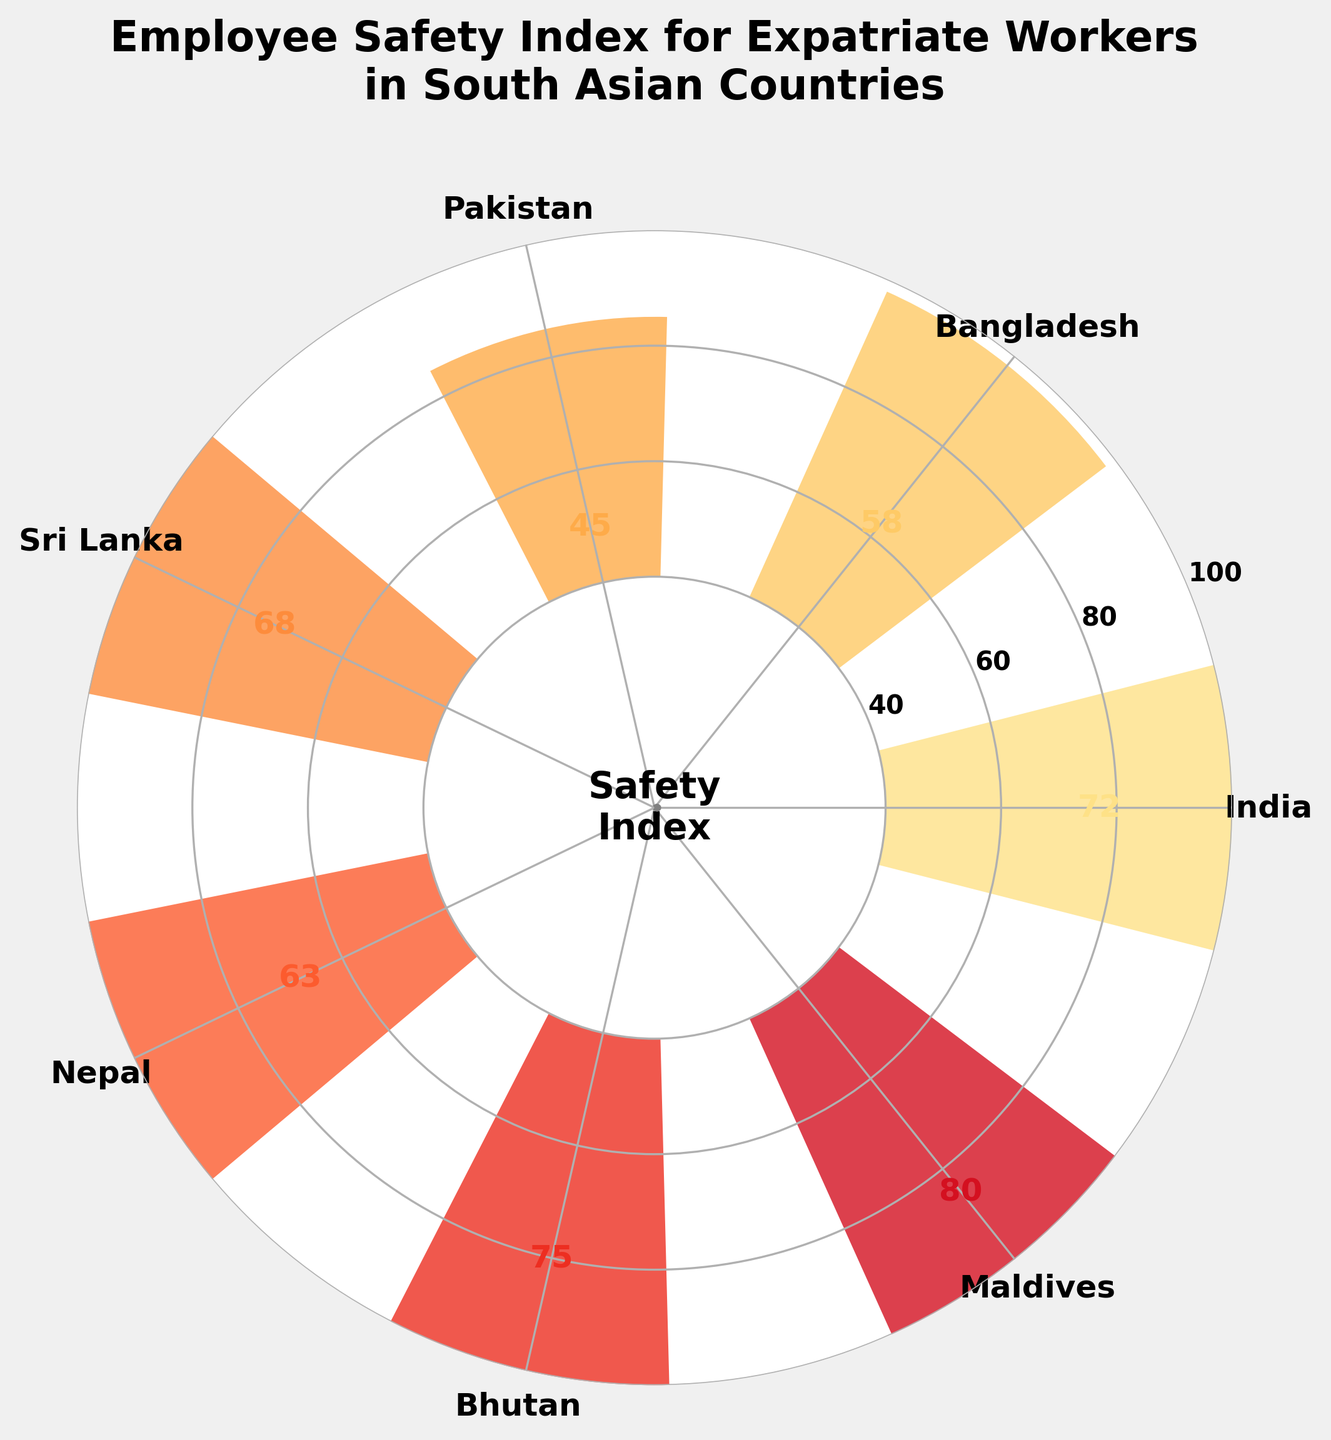What's the title of the figure? The title of the figure is located at the top of the plot, highlighting the main subject or theme of the chart. It reads 'Employee Safety Index for Expatriate Workers in South Asian Countries' as it summarizes the data being visualized.
Answer: 'Employee Safety Index for Expatriate Workers in South Asian Countries' How many countries are included in the safety index radar chart? By counting the number of unique labels around the edge of the radar chart, we can determine that there are seven different countries included in the safety index radar chart.
Answer: Seven Which country has the highest employee safety index? By observing the height of the bars in the radar chart, the Maldives bar reaches the highest value. Thus, the Maldives has the highest employee safety index.
Answer: Maldives What is the range of the employee safety index values? The range is calculated by subtracting the smallest value observed in the chart (Pakistan with 45) from the largest value (Maldives with 80).
Answer: 35 Which country has a lower safety index, Bangladesh or Nepal? By comparing the heights of the bars labeled for Bangladesh and Nepal, we can see that Bangladesh (58) has a lower safety index than Nepal (63).
Answer: Bangladesh What's the difference in safety index between the country with the highest index and the country with the lowest index? The highest safety index value is 80 (Maldives) and the lowest is 45 (Pakistan). The difference is obtained by subtracting the lowest value from the highest: 80 - 45.
Answer: 35 How many countries have an employee safety index of at least 60? By examining the values listed around the radar chart, we note that India (72), Sri Lanka (68), Nepal (63), Bhutan (75), and Maldives (80) all have values of 60 or above, totaling five countries.
Answer: Five What is the average safety index for all the countries? To find the average, sum all safety index values (72 + 58 + 45 + 68 + 63 + 75 + 80 = 461) and divide by the total number of countries (7). Thus, the average safety index is 461 / 7 ≈ 65.86.
Answer: 65.86 Does Bhutan have a higher employee safety index than Sri Lanka? By comparing the bar heights, Bhutan (75) is higher than Sri Lanka (68), indicating that Bhutan has a higher employee safety index.
Answer: Yes What is the median safety index value in the chart? Arrange all safety index values in ascending order: 45, 58, 63, 68, 72, 75, 80. The median value is the middle number, which in this case is 68 (Sri Lanka).
Answer: 68 